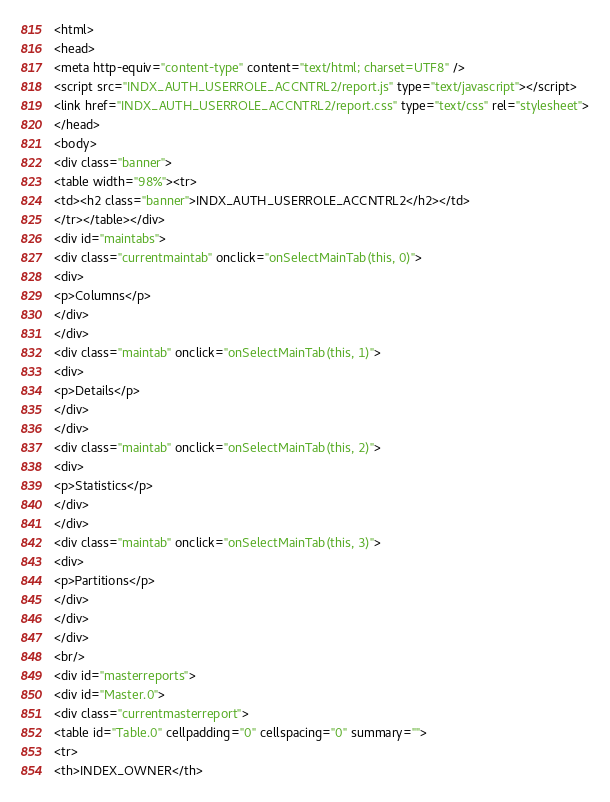<code> <loc_0><loc_0><loc_500><loc_500><_HTML_><html>
<head>
<meta http-equiv="content-type" content="text/html; charset=UTF8" />
<script src="INDX_AUTH_USERROLE_ACCNTRL2/report.js" type="text/javascript"></script>
<link href="INDX_AUTH_USERROLE_ACCNTRL2/report.css" type="text/css" rel="stylesheet">
</head>
<body>
<div class="banner">
<table width="98%"><tr>
<td><h2 class="banner">INDX_AUTH_USERROLE_ACCNTRL2</h2></td>
</tr></table></div>
<div id="maintabs">
<div class="currentmaintab" onclick="onSelectMainTab(this, 0)">
<div>
<p>Columns</p>
</div>
</div>
<div class="maintab" onclick="onSelectMainTab(this, 1)">
<div>
<p>Details</p>
</div>
</div>
<div class="maintab" onclick="onSelectMainTab(this, 2)">
<div>
<p>Statistics</p>
</div>
</div>
<div class="maintab" onclick="onSelectMainTab(this, 3)">
<div>
<p>Partitions</p>
</div>
</div>
</div>
<br/>
<div id="masterreports">
<div id="Master.0">
<div class="currentmasterreport">
<table id="Table.0" cellpadding="0" cellspacing="0" summary="">
<tr>
<th>INDEX_OWNER</th></code> 